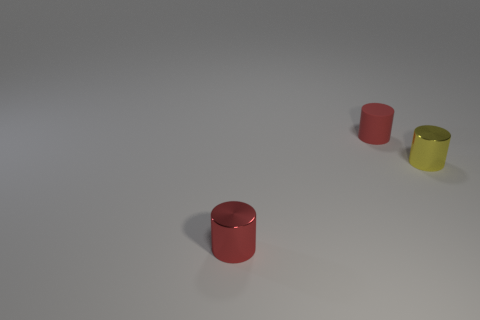What is the material of the cylinder that is the same color as the matte object?
Offer a very short reply. Metal. How many yellow shiny objects are to the right of the yellow cylinder?
Ensure brevity in your answer.  0. Does the tiny cylinder in front of the tiny yellow metal cylinder have the same material as the tiny yellow cylinder?
Provide a succinct answer. Yes. How many small red objects have the same shape as the small yellow object?
Keep it short and to the point. 2. How many large things are either metal cylinders or red rubber cylinders?
Provide a succinct answer. 0. Is the color of the small metal cylinder that is to the right of the red rubber cylinder the same as the small rubber cylinder?
Your answer should be compact. No. Do the thing to the left of the tiny red rubber cylinder and the rubber cylinder that is behind the yellow object have the same color?
Ensure brevity in your answer.  Yes. Is there a tiny red cylinder made of the same material as the yellow cylinder?
Ensure brevity in your answer.  Yes. What number of red things are either small cylinders or shiny things?
Your response must be concise. 2. Are there more red cylinders in front of the red matte thing than big green matte cylinders?
Ensure brevity in your answer.  Yes. 